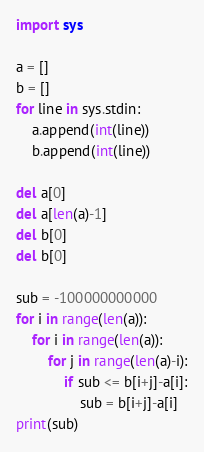<code> <loc_0><loc_0><loc_500><loc_500><_Python_>import sys

a = []
b = []
for line in sys.stdin:
    a.append(int(line))
    b.append(int(line))

del a[0]
del a[len(a)-1]
del b[0]
del b[0]

sub = -100000000000
for i in range(len(a)):
    for i in range(len(a)):
        for j in range(len(a)-i):
            if sub <= b[i+j]-a[i]:
                sub = b[i+j]-a[i]
print(sub)
</code> 